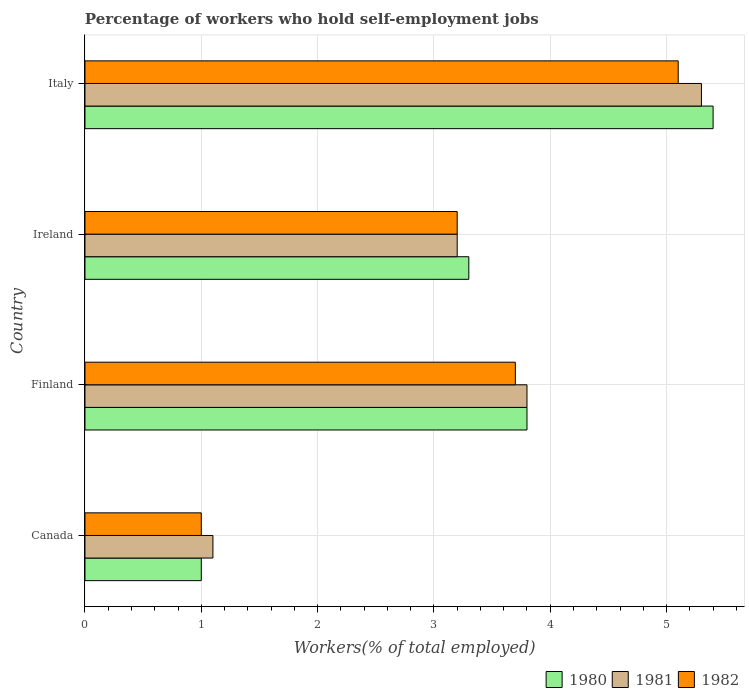How many different coloured bars are there?
Make the answer very short. 3. How many groups of bars are there?
Make the answer very short. 4. How many bars are there on the 4th tick from the top?
Make the answer very short. 3. How many bars are there on the 4th tick from the bottom?
Offer a very short reply. 3. What is the label of the 2nd group of bars from the top?
Ensure brevity in your answer.  Ireland. In how many cases, is the number of bars for a given country not equal to the number of legend labels?
Offer a very short reply. 0. What is the percentage of self-employed workers in 1981 in Finland?
Ensure brevity in your answer.  3.8. Across all countries, what is the maximum percentage of self-employed workers in 1982?
Give a very brief answer. 5.1. What is the total percentage of self-employed workers in 1980 in the graph?
Offer a very short reply. 13.5. What is the difference between the percentage of self-employed workers in 1981 in Canada and that in Finland?
Provide a short and direct response. -2.7. What is the difference between the percentage of self-employed workers in 1981 in Italy and the percentage of self-employed workers in 1982 in Ireland?
Ensure brevity in your answer.  2.1. What is the average percentage of self-employed workers in 1980 per country?
Keep it short and to the point. 3.37. What is the difference between the percentage of self-employed workers in 1981 and percentage of self-employed workers in 1982 in Ireland?
Provide a short and direct response. 0. In how many countries, is the percentage of self-employed workers in 1980 greater than 5.2 %?
Your response must be concise. 1. What is the ratio of the percentage of self-employed workers in 1981 in Canada to that in Ireland?
Your answer should be compact. 0.34. Is the percentage of self-employed workers in 1981 in Canada less than that in Finland?
Your answer should be compact. Yes. What is the difference between the highest and the second highest percentage of self-employed workers in 1980?
Make the answer very short. 1.6. What is the difference between the highest and the lowest percentage of self-employed workers in 1982?
Your answer should be very brief. 4.1. Are the values on the major ticks of X-axis written in scientific E-notation?
Offer a very short reply. No. Where does the legend appear in the graph?
Offer a very short reply. Bottom right. What is the title of the graph?
Offer a terse response. Percentage of workers who hold self-employment jobs. What is the label or title of the X-axis?
Keep it short and to the point. Workers(% of total employed). What is the Workers(% of total employed) in 1980 in Canada?
Give a very brief answer. 1. What is the Workers(% of total employed) of 1981 in Canada?
Keep it short and to the point. 1.1. What is the Workers(% of total employed) in 1980 in Finland?
Your answer should be compact. 3.8. What is the Workers(% of total employed) in 1981 in Finland?
Your response must be concise. 3.8. What is the Workers(% of total employed) in 1982 in Finland?
Ensure brevity in your answer.  3.7. What is the Workers(% of total employed) of 1980 in Ireland?
Your answer should be very brief. 3.3. What is the Workers(% of total employed) in 1981 in Ireland?
Make the answer very short. 3.2. What is the Workers(% of total employed) of 1982 in Ireland?
Your answer should be compact. 3.2. What is the Workers(% of total employed) of 1980 in Italy?
Ensure brevity in your answer.  5.4. What is the Workers(% of total employed) in 1981 in Italy?
Your response must be concise. 5.3. What is the Workers(% of total employed) in 1982 in Italy?
Offer a terse response. 5.1. Across all countries, what is the maximum Workers(% of total employed) in 1980?
Your answer should be compact. 5.4. Across all countries, what is the maximum Workers(% of total employed) of 1981?
Give a very brief answer. 5.3. Across all countries, what is the maximum Workers(% of total employed) of 1982?
Give a very brief answer. 5.1. Across all countries, what is the minimum Workers(% of total employed) in 1980?
Offer a terse response. 1. Across all countries, what is the minimum Workers(% of total employed) in 1981?
Offer a terse response. 1.1. What is the total Workers(% of total employed) in 1982 in the graph?
Provide a succinct answer. 13. What is the difference between the Workers(% of total employed) in 1980 in Canada and that in Finland?
Your answer should be compact. -2.8. What is the difference between the Workers(% of total employed) in 1982 in Canada and that in Finland?
Provide a short and direct response. -2.7. What is the difference between the Workers(% of total employed) of 1980 in Canada and that in Ireland?
Keep it short and to the point. -2.3. What is the difference between the Workers(% of total employed) in 1981 in Canada and that in Ireland?
Offer a terse response. -2.1. What is the difference between the Workers(% of total employed) in 1981 in Canada and that in Italy?
Make the answer very short. -4.2. What is the difference between the Workers(% of total employed) of 1980 in Finland and that in Ireland?
Make the answer very short. 0.5. What is the difference between the Workers(% of total employed) in 1981 in Finland and that in Ireland?
Your answer should be compact. 0.6. What is the difference between the Workers(% of total employed) of 1982 in Finland and that in Ireland?
Your answer should be very brief. 0.5. What is the difference between the Workers(% of total employed) in 1980 in Finland and that in Italy?
Provide a short and direct response. -1.6. What is the difference between the Workers(% of total employed) of 1982 in Finland and that in Italy?
Make the answer very short. -1.4. What is the difference between the Workers(% of total employed) of 1981 in Ireland and that in Italy?
Your answer should be compact. -2.1. What is the difference between the Workers(% of total employed) in 1982 in Ireland and that in Italy?
Your response must be concise. -1.9. What is the difference between the Workers(% of total employed) in 1980 in Canada and the Workers(% of total employed) in 1981 in Finland?
Ensure brevity in your answer.  -2.8. What is the difference between the Workers(% of total employed) in 1981 in Canada and the Workers(% of total employed) in 1982 in Finland?
Your answer should be compact. -2.6. What is the difference between the Workers(% of total employed) of 1981 in Canada and the Workers(% of total employed) of 1982 in Ireland?
Provide a succinct answer. -2.1. What is the difference between the Workers(% of total employed) of 1980 in Canada and the Workers(% of total employed) of 1981 in Italy?
Your response must be concise. -4.3. What is the difference between the Workers(% of total employed) in 1980 in Finland and the Workers(% of total employed) in 1981 in Ireland?
Keep it short and to the point. 0.6. What is the difference between the Workers(% of total employed) of 1980 in Finland and the Workers(% of total employed) of 1982 in Ireland?
Offer a terse response. 0.6. What is the difference between the Workers(% of total employed) in 1980 in Finland and the Workers(% of total employed) in 1981 in Italy?
Give a very brief answer. -1.5. What is the difference between the Workers(% of total employed) in 1981 in Finland and the Workers(% of total employed) in 1982 in Italy?
Offer a very short reply. -1.3. What is the difference between the Workers(% of total employed) of 1980 in Ireland and the Workers(% of total employed) of 1981 in Italy?
Your response must be concise. -2. What is the average Workers(% of total employed) in 1980 per country?
Give a very brief answer. 3.38. What is the average Workers(% of total employed) of 1981 per country?
Keep it short and to the point. 3.35. What is the difference between the Workers(% of total employed) of 1980 and Workers(% of total employed) of 1981 in Canada?
Ensure brevity in your answer.  -0.1. What is the difference between the Workers(% of total employed) in 1980 and Workers(% of total employed) in 1982 in Finland?
Ensure brevity in your answer.  0.1. What is the difference between the Workers(% of total employed) in 1981 and Workers(% of total employed) in 1982 in Finland?
Your answer should be compact. 0.1. What is the difference between the Workers(% of total employed) in 1980 and Workers(% of total employed) in 1981 in Ireland?
Provide a succinct answer. 0.1. What is the ratio of the Workers(% of total employed) of 1980 in Canada to that in Finland?
Your response must be concise. 0.26. What is the ratio of the Workers(% of total employed) of 1981 in Canada to that in Finland?
Provide a short and direct response. 0.29. What is the ratio of the Workers(% of total employed) in 1982 in Canada to that in Finland?
Offer a very short reply. 0.27. What is the ratio of the Workers(% of total employed) in 1980 in Canada to that in Ireland?
Offer a very short reply. 0.3. What is the ratio of the Workers(% of total employed) of 1981 in Canada to that in Ireland?
Provide a short and direct response. 0.34. What is the ratio of the Workers(% of total employed) of 1982 in Canada to that in Ireland?
Keep it short and to the point. 0.31. What is the ratio of the Workers(% of total employed) of 1980 in Canada to that in Italy?
Ensure brevity in your answer.  0.19. What is the ratio of the Workers(% of total employed) of 1981 in Canada to that in Italy?
Ensure brevity in your answer.  0.21. What is the ratio of the Workers(% of total employed) in 1982 in Canada to that in Italy?
Offer a very short reply. 0.2. What is the ratio of the Workers(% of total employed) of 1980 in Finland to that in Ireland?
Make the answer very short. 1.15. What is the ratio of the Workers(% of total employed) of 1981 in Finland to that in Ireland?
Offer a very short reply. 1.19. What is the ratio of the Workers(% of total employed) in 1982 in Finland to that in Ireland?
Keep it short and to the point. 1.16. What is the ratio of the Workers(% of total employed) of 1980 in Finland to that in Italy?
Keep it short and to the point. 0.7. What is the ratio of the Workers(% of total employed) in 1981 in Finland to that in Italy?
Provide a short and direct response. 0.72. What is the ratio of the Workers(% of total employed) of 1982 in Finland to that in Italy?
Offer a very short reply. 0.73. What is the ratio of the Workers(% of total employed) in 1980 in Ireland to that in Italy?
Provide a short and direct response. 0.61. What is the ratio of the Workers(% of total employed) of 1981 in Ireland to that in Italy?
Your answer should be compact. 0.6. What is the ratio of the Workers(% of total employed) of 1982 in Ireland to that in Italy?
Ensure brevity in your answer.  0.63. What is the difference between the highest and the second highest Workers(% of total employed) of 1980?
Provide a short and direct response. 1.6. What is the difference between the highest and the second highest Workers(% of total employed) in 1981?
Give a very brief answer. 1.5. What is the difference between the highest and the second highest Workers(% of total employed) of 1982?
Make the answer very short. 1.4. What is the difference between the highest and the lowest Workers(% of total employed) in 1981?
Make the answer very short. 4.2. What is the difference between the highest and the lowest Workers(% of total employed) in 1982?
Your response must be concise. 4.1. 